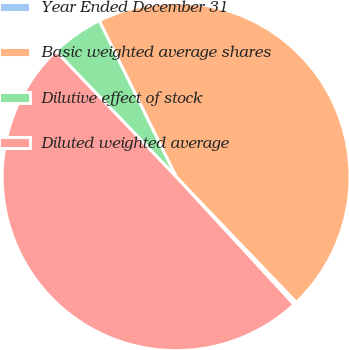<chart> <loc_0><loc_0><loc_500><loc_500><pie_chart><fcel>Year Ended December 31<fcel>Basic weighted average shares<fcel>Dilutive effect of stock<fcel>Diluted weighted average<nl><fcel>0.3%<fcel>45.13%<fcel>4.87%<fcel>49.7%<nl></chart> 